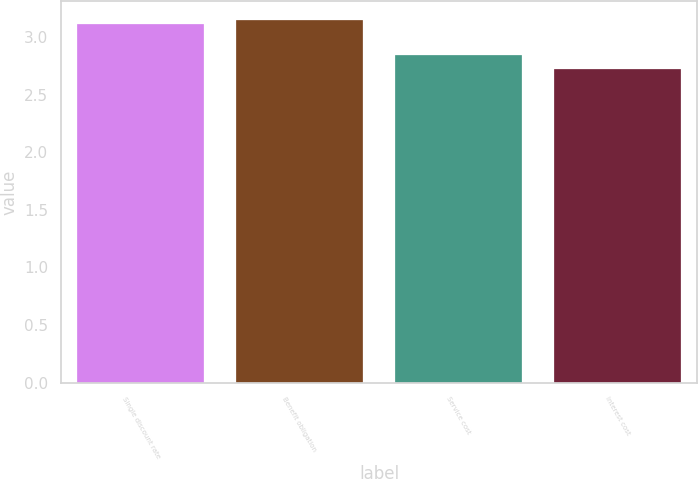Convert chart. <chart><loc_0><loc_0><loc_500><loc_500><bar_chart><fcel>Single discount rate<fcel>Benefit obligation<fcel>Service cost<fcel>Interest cost<nl><fcel>3.11<fcel>3.15<fcel>2.84<fcel>2.72<nl></chart> 